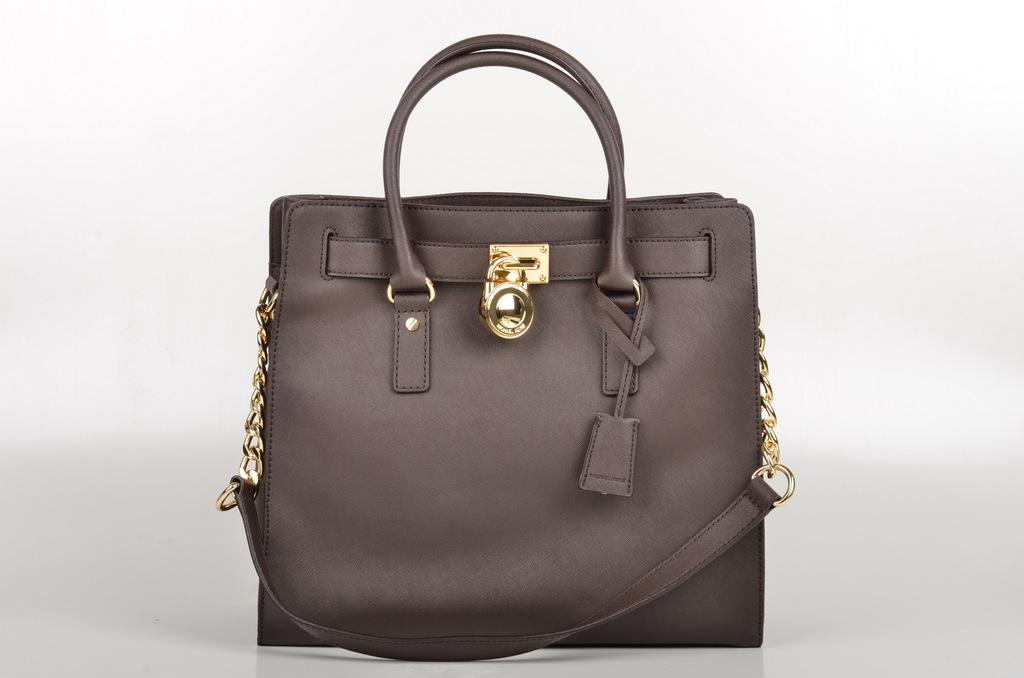What type of bag is visible in the image? The bag is a handbag. What are the chains on the bag made of? The chains on the bag are made of golden color material. How is the bag secured? The bag has a small lock. What is the color of the bag? The bag is brown in color. On what surface is the bag placed? The bag is placed on a white color table. What type of flowers can be seen growing out of the bag in the image? There are no flowers growing out of the bag in the image; it is a handbag with golden chains, a small lock, and a brown color. 